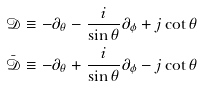Convert formula to latex. <formula><loc_0><loc_0><loc_500><loc_500>\mathcal { D } & \equiv - \partial _ { \theta } - \frac { i } { \sin \theta } \partial _ { \phi } + j \cot \theta \\ \bar { \mathcal { D } } & \equiv - \partial _ { \theta } + \frac { i } { \sin \theta } \partial _ { \phi } - j \cot \theta</formula> 